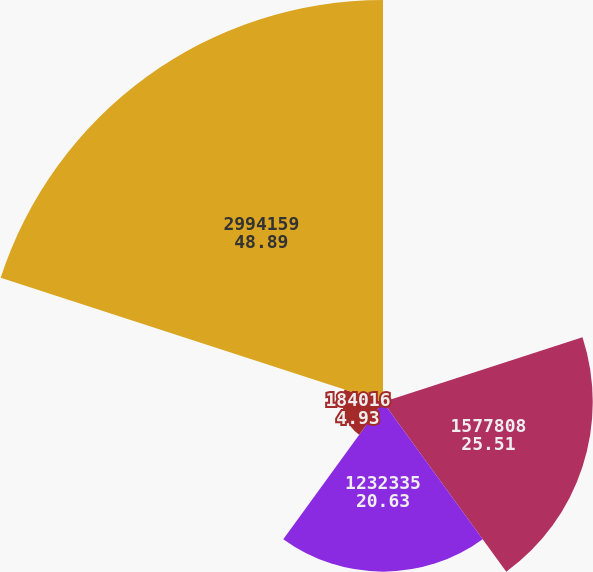Convert chart. <chart><loc_0><loc_0><loc_500><loc_500><pie_chart><fcel>2008<fcel>1577808<fcel>1232335<fcel>184016<fcel>2994159<nl><fcel>0.04%<fcel>25.51%<fcel>20.63%<fcel>4.93%<fcel>48.89%<nl></chart> 